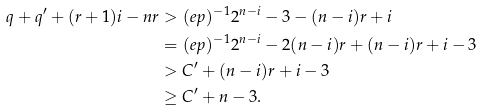Convert formula to latex. <formula><loc_0><loc_0><loc_500><loc_500>q + q ^ { \prime } + ( r + 1 ) i - n r & > ( e p ) ^ { - 1 } 2 ^ { n - i } - 3 - ( n - i ) r + i \\ & = ( e p ) ^ { - 1 } 2 ^ { n - i } - 2 ( n - i ) r + ( n - i ) r + i - 3 \\ & > C ^ { \prime } + ( n - i ) r + i - 3 \\ & \geq C ^ { \prime } + n - 3 .</formula> 